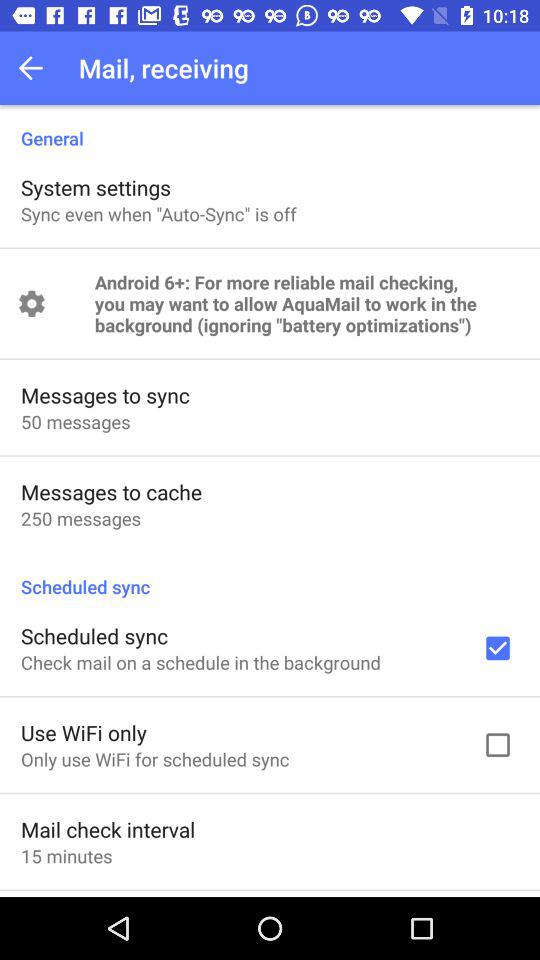How many more messages are there to cache than to sync?
Answer the question using a single word or phrase. 200 